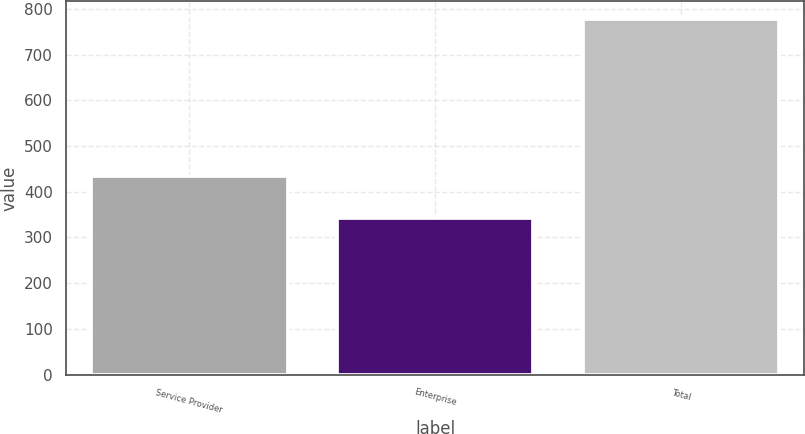<chart> <loc_0><loc_0><loc_500><loc_500><bar_chart><fcel>Service Provider<fcel>Enterprise<fcel>Total<nl><fcel>434.4<fcel>343<fcel>777.4<nl></chart> 